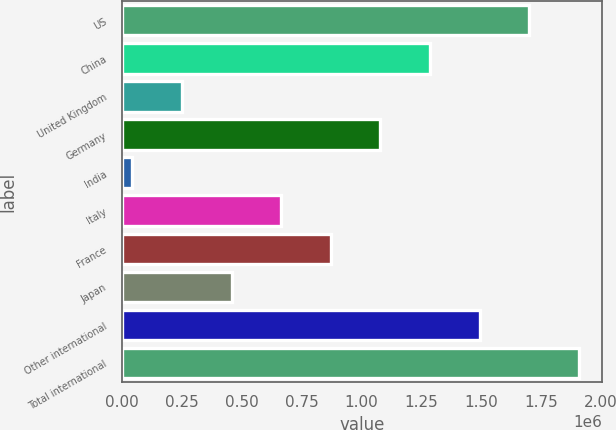Convert chart to OTSL. <chart><loc_0><loc_0><loc_500><loc_500><bar_chart><fcel>US<fcel>China<fcel>United Kingdom<fcel>Germany<fcel>India<fcel>Italy<fcel>France<fcel>Japan<fcel>Other international<fcel>Total international<nl><fcel>1.70119e+06<fcel>1.28687e+06<fcel>251054<fcel>1.0797e+06<fcel>43891<fcel>665379<fcel>872541<fcel>458216<fcel>1.49403e+06<fcel>1.90835e+06<nl></chart> 